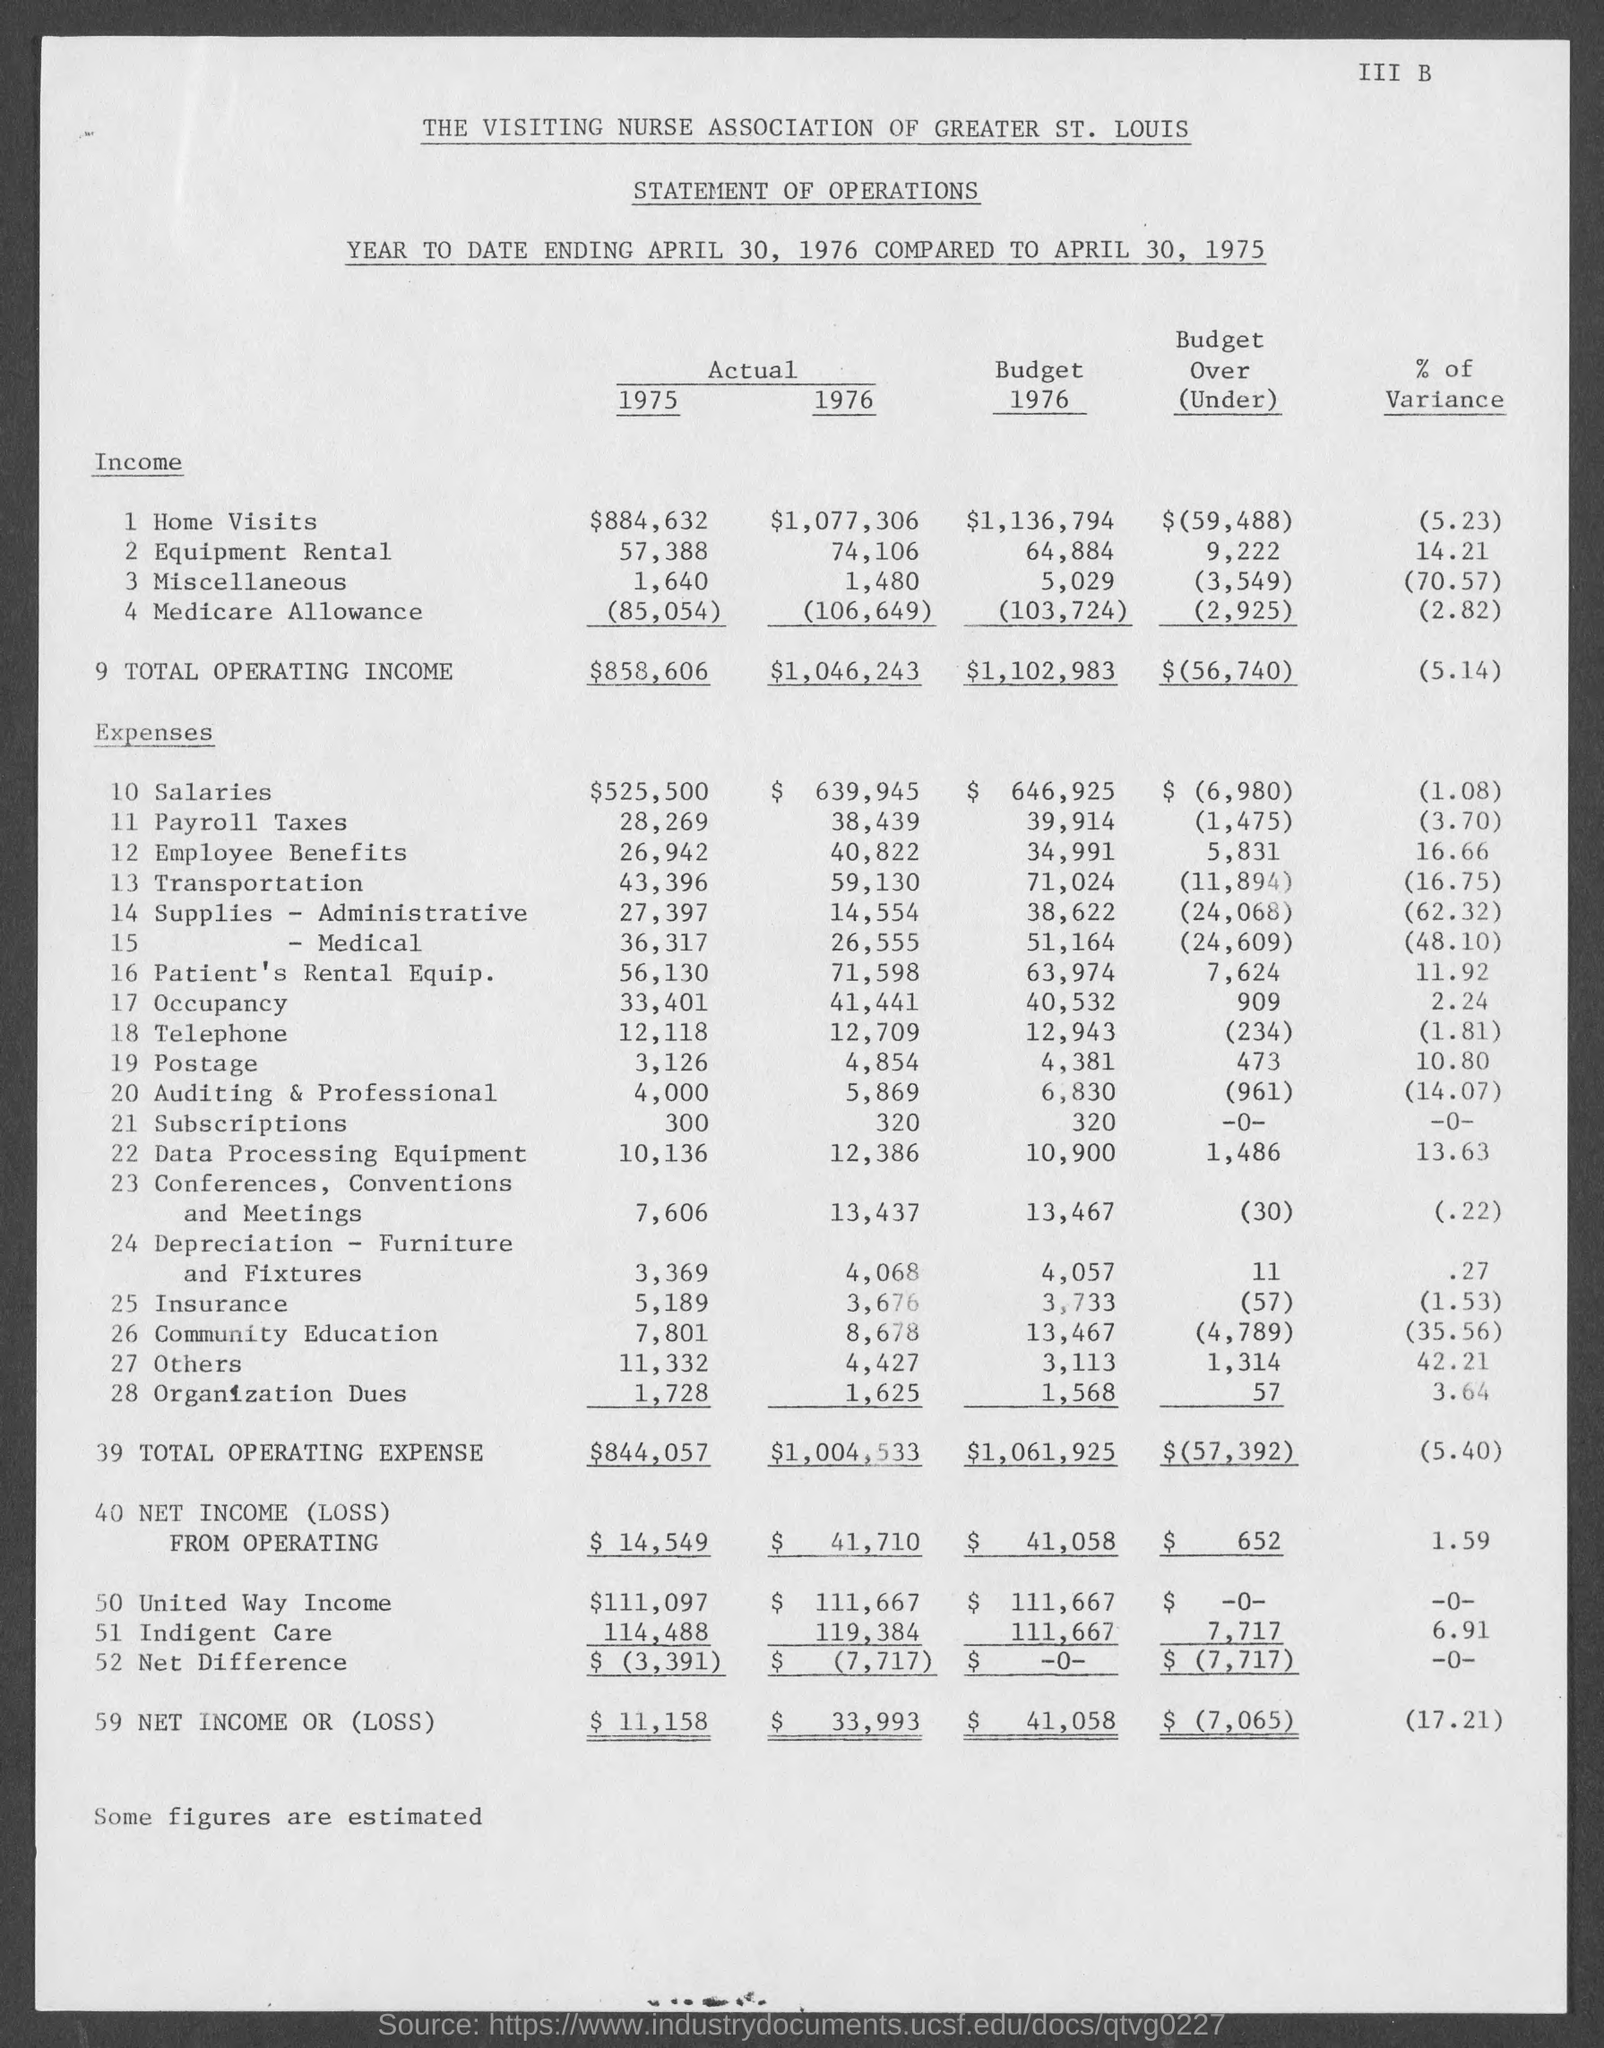List a handful of essential elements in this visual. The actual income for Medicare allowance for 1975 is $85,054. In 1976, the budget income for home visits was $1,136,794. The actual income for miscellaneous expenses for 1976 is 1,480. The actual income for home visits in 1976 was $1,077,306. The actual income for equipment rental in 1975 was $57,388. 